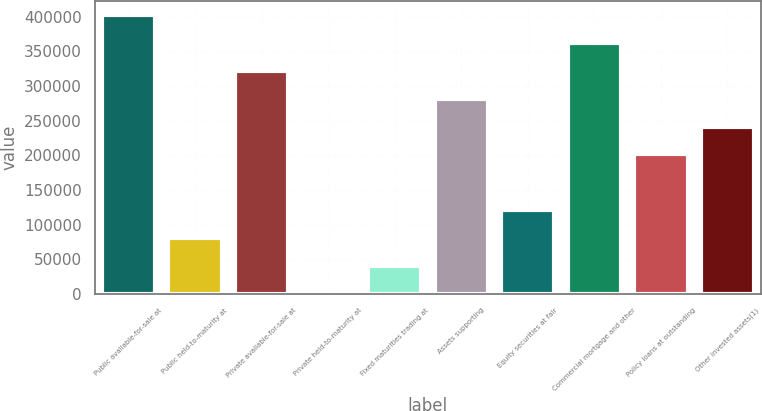Convert chart to OTSL. <chart><loc_0><loc_0><loc_500><loc_500><bar_chart><fcel>Public available-for-sale at<fcel>Public held-to-maturity at<fcel>Private available-for-sale at<fcel>Private held-to-maturity at<fcel>Fixed maturities trading at<fcel>Assets supporting<fcel>Equity securities at fair<fcel>Commercial mortgage and other<fcel>Policy loans at outstanding<fcel>Other invested assets(1)<nl><fcel>402275<fcel>80696.6<fcel>321880<fcel>302<fcel>40499.3<fcel>281683<fcel>120894<fcel>362078<fcel>201288<fcel>241486<nl></chart> 